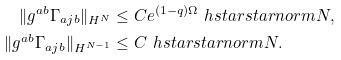<formula> <loc_0><loc_0><loc_500><loc_500>\| g ^ { a b } \Gamma _ { a j b } \| _ { H ^ { N } } & \leq C e ^ { ( 1 - q ) \Omega } \ h s t a r s t a r n o r m { N } , \\ \| g ^ { a b } \Gamma _ { a j b } \| _ { H ^ { N - 1 } } & \leq C \ h s t a r s t a r n o r m { N } .</formula> 